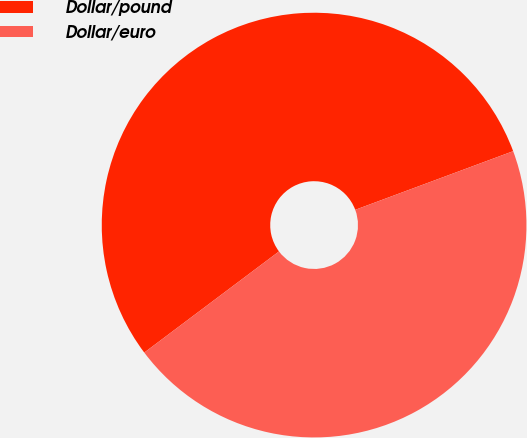Convert chart to OTSL. <chart><loc_0><loc_0><loc_500><loc_500><pie_chart><fcel>Dollar/pound<fcel>Dollar/euro<nl><fcel>54.59%<fcel>45.41%<nl></chart> 